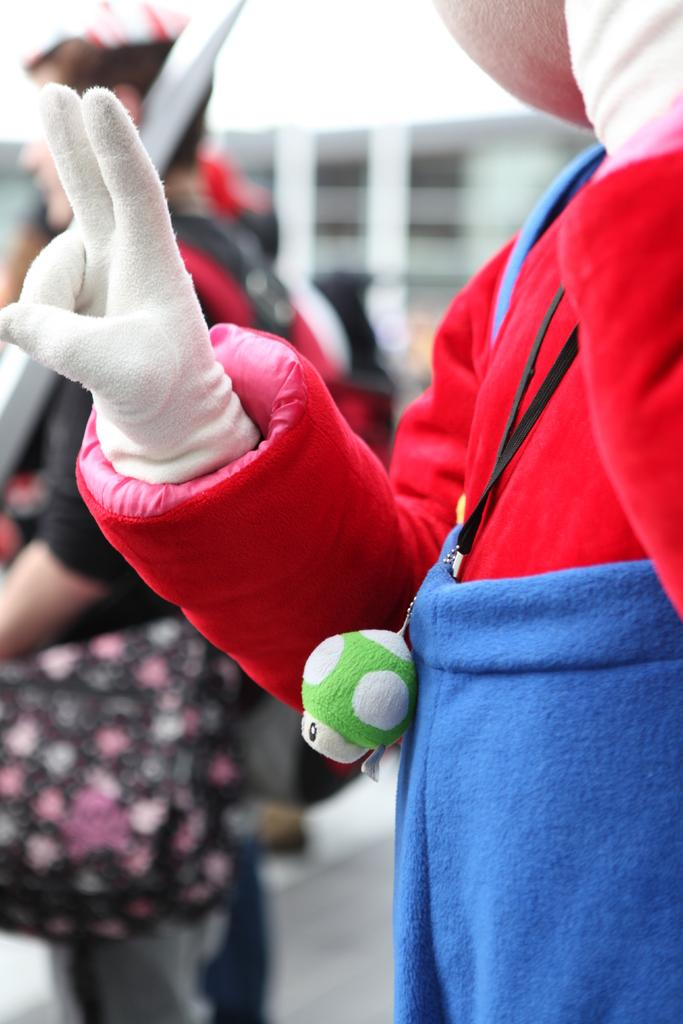How many people are in the image? There are persons in the image, but the exact number is not specified. What are the persons wearing? The persons are wearing clothes. Can you describe the background of the image? The background of the image is blurred. What type of treatment is the person receiving in the image? There is no indication of any treatment being administered in the image. Is the person wearing a mask in the image? There is no mention of a mask in the image. 